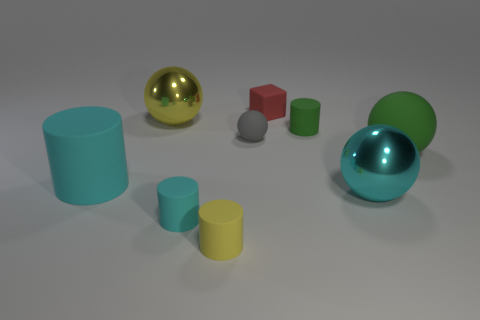How many small rubber objects have the same color as the large rubber cylinder?
Provide a succinct answer. 1. There is a green rubber ball; are there any cyan shiny things in front of it?
Your answer should be compact. Yes. Is there a green matte cylinder that is to the right of the green rubber thing left of the large metal object that is on the right side of the red matte thing?
Your answer should be compact. No. Does the yellow object that is in front of the big rubber cylinder have the same shape as the tiny green thing?
Provide a succinct answer. Yes. There is a tiny block that is made of the same material as the tiny yellow cylinder; what color is it?
Your answer should be compact. Red. How many red things have the same material as the tiny green thing?
Your answer should be compact. 1. The big shiny object that is to the right of the metallic sphere that is on the left side of the large cyan object that is to the right of the yellow shiny sphere is what color?
Your response must be concise. Cyan. Do the gray matte thing and the red matte thing have the same size?
Keep it short and to the point. Yes. Is there anything else that is the same shape as the large yellow thing?
Provide a succinct answer. Yes. What number of things are either matte objects to the left of the tiny yellow matte thing or purple rubber balls?
Make the answer very short. 2. 